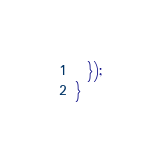<code> <loc_0><loc_0><loc_500><loc_500><_TypeScript_>  });
}
</code> 